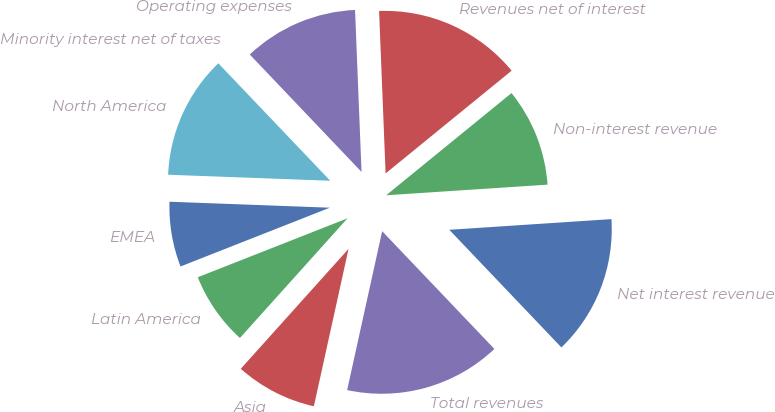Convert chart. <chart><loc_0><loc_0><loc_500><loc_500><pie_chart><fcel>Net interest revenue<fcel>Non-interest revenue<fcel>Revenues net of interest<fcel>Operating expenses<fcel>Minority interest net of taxes<fcel>North America<fcel>EMEA<fcel>Latin America<fcel>Asia<fcel>Total revenues<nl><fcel>13.93%<fcel>9.84%<fcel>14.75%<fcel>11.47%<fcel>0.01%<fcel>12.29%<fcel>6.56%<fcel>7.38%<fcel>8.2%<fcel>15.57%<nl></chart> 